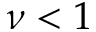Convert formula to latex. <formula><loc_0><loc_0><loc_500><loc_500>\nu < 1</formula> 